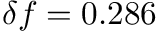Convert formula to latex. <formula><loc_0><loc_0><loc_500><loc_500>\delta f = 0 . 2 8 6</formula> 